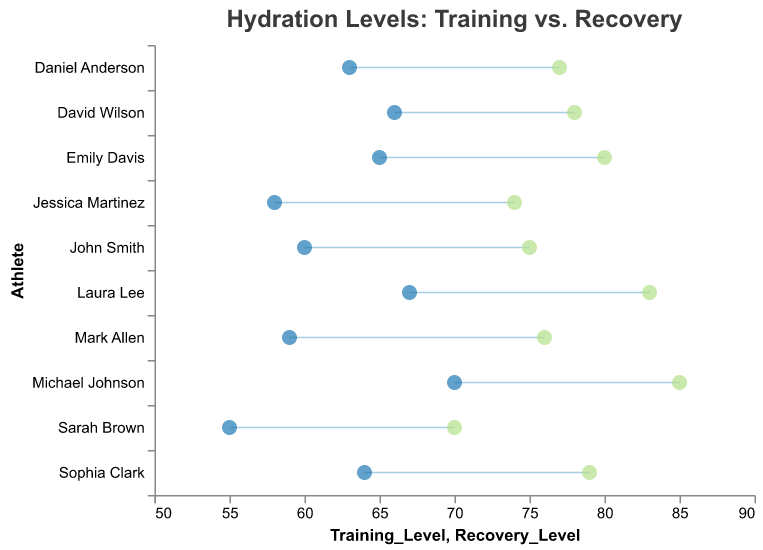What is the title of the plot? The title of the plot is shown at the top of the figure.
Answer: Hydration Levels: Training vs. Recovery How many athletes' hydration levels are depicted in the plot? We can count the number of unique names on the y-axis.
Answer: 10 Which athlete has the highest training level? Identify the athlete whom `Training_Level` point is farthest to the right.
Answer: Michael Johnson Which athlete shows the greatest improvement in hydration level from training to recovery? Calculate the difference between `Recovery_Level` and `Training_Level` for each athlete and find the largest value.
Answer: Michael Johnson Is there any athlete whose hydration level remains the same during training and recovery? Check if any athlete has the same value for `Training_Level` and `Recovery_Level`.
Answer: No What is the average recovery hydration level of all athletes? Add up all `Recovery_Level` values and divide by the number of athletes. Calculation: (75 + 80 + 85 + 70 + 78 + 74 + 77 + 83 + 76 + 79)/10
Answer: 77.7 How many athletes have a training level below 60? Count the number of athletes whose `Training_Level` values are less than 60.
Answer: 3 Who has the lowest training hydration level? Identify the athlete whose `Training_Level` point is farthest to the left.
Answer: Sarah Brown Which athlete has a recovery level exactly 10 units higher than their training level? Subtract the `Training_Level` from `Recovery_Level` for each athlete and check who has a difference of 10.
Answer: Laura Lee For which athletes is the hydation increase greater than 10 units? Identify athletes where the difference between `Recovery_Level` and `Training_Level` is greater than 10.
Answer: Emily Davis, Michael Johnson, Laura Lee Which athletes have a recovery level of 79? Look at the x-axis points in the `Recovery_Level` and identify the corresponding y-axis label(s).
Answer: Sophia Clark 